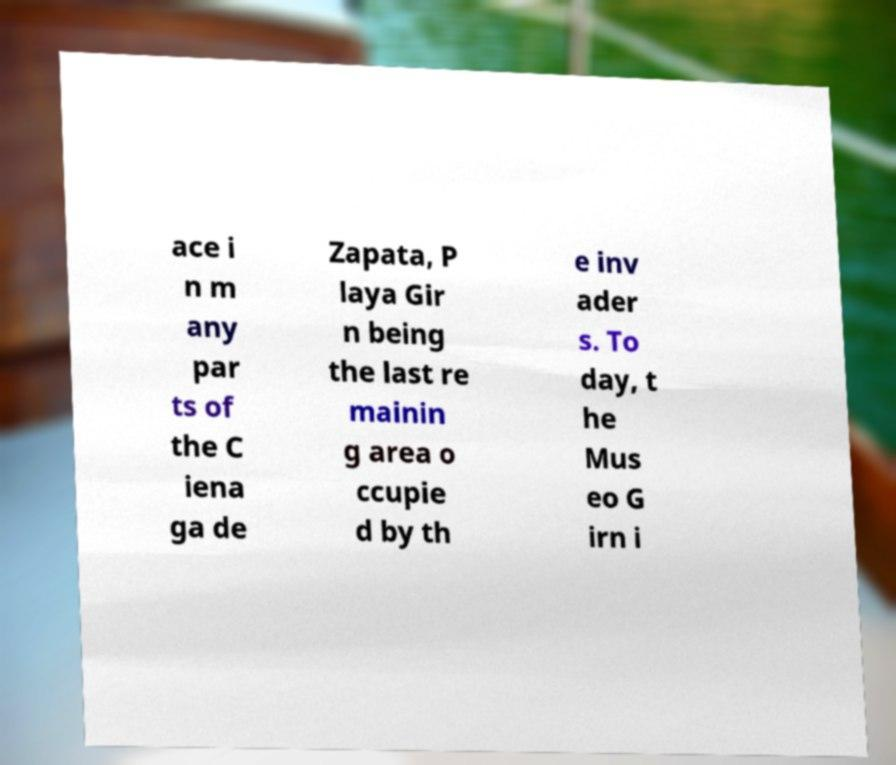Could you extract and type out the text from this image? ace i n m any par ts of the C iena ga de Zapata, P laya Gir n being the last re mainin g area o ccupie d by th e inv ader s. To day, t he Mus eo G irn i 